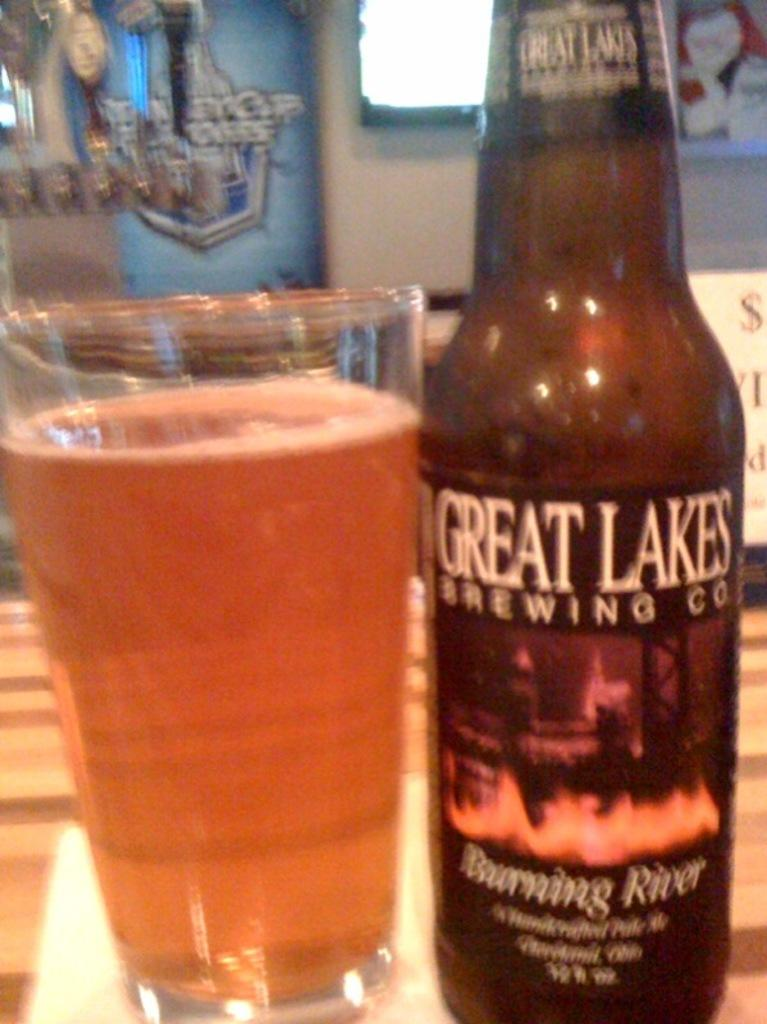<image>
Render a clear and concise summary of the photo. A cup of beer sitting next to a bottle that says  Great Lakes brewing co. on it. 